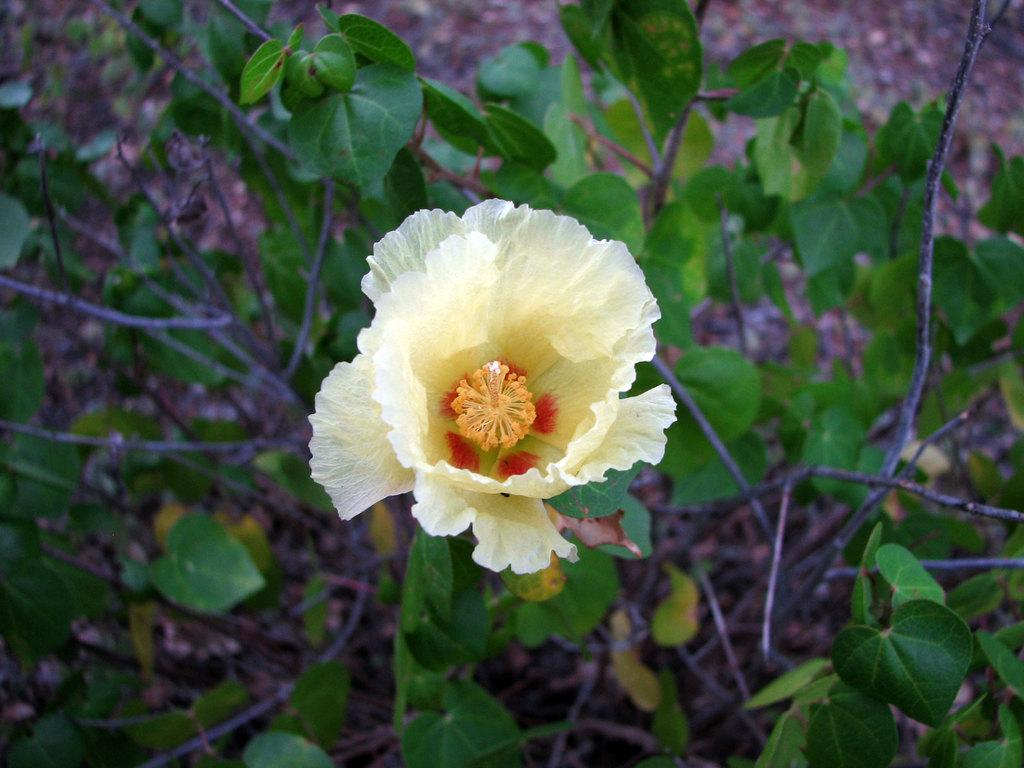What type of plant can be seen in the image? There is a flower in the image. Are there any other plants visible in the image? Yes, there are plants in the image. Can you describe the background of the image? The background of the image is blurry. Can you tell me how the zephyr affects the plants in the image? There is no mention of a zephyr or any wind in the image, so we cannot determine its effect on the plants. 